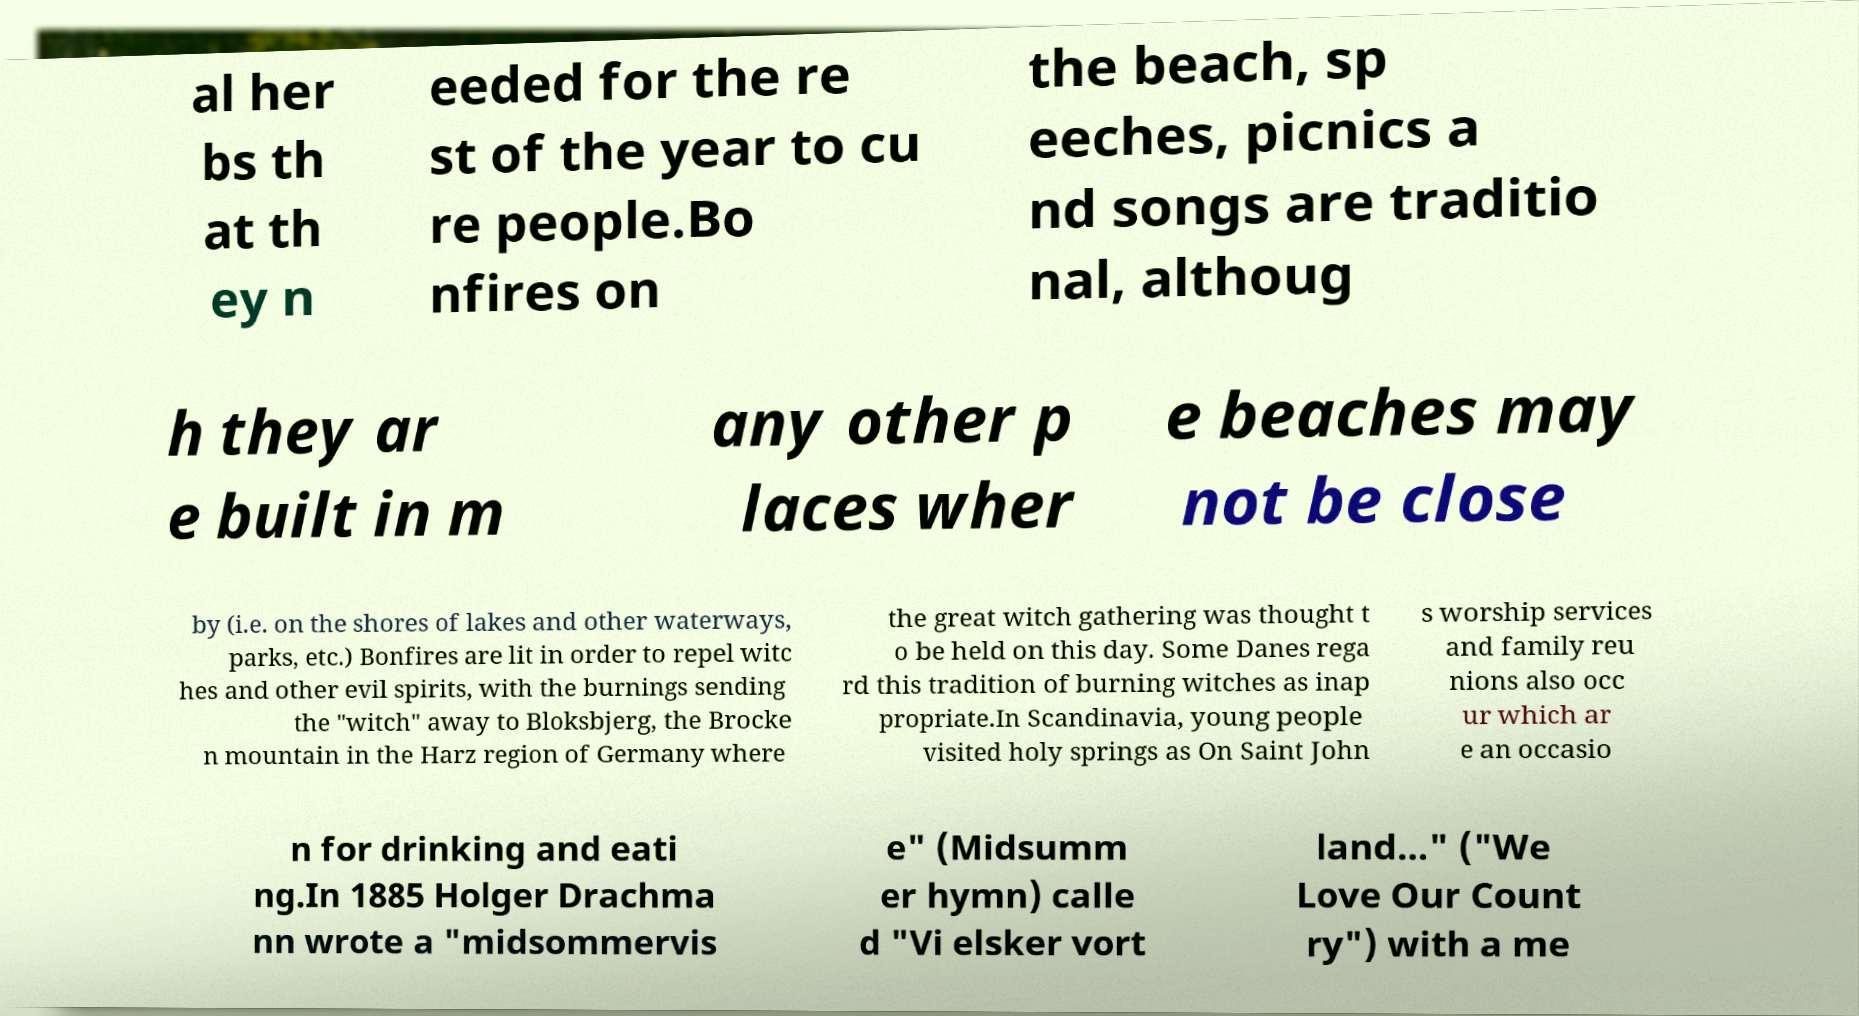What messages or text are displayed in this image? I need them in a readable, typed format. al her bs th at th ey n eeded for the re st of the year to cu re people.Bo nfires on the beach, sp eeches, picnics a nd songs are traditio nal, althoug h they ar e built in m any other p laces wher e beaches may not be close by (i.e. on the shores of lakes and other waterways, parks, etc.) Bonfires are lit in order to repel witc hes and other evil spirits, with the burnings sending the "witch" away to Bloksbjerg, the Brocke n mountain in the Harz region of Germany where the great witch gathering was thought t o be held on this day. Some Danes rega rd this tradition of burning witches as inap propriate.In Scandinavia, young people visited holy springs as On Saint John s worship services and family reu nions also occ ur which ar e an occasio n for drinking and eati ng.In 1885 Holger Drachma nn wrote a "midsommervis e" (Midsumm er hymn) calle d "Vi elsker vort land..." ("We Love Our Count ry") with a me 